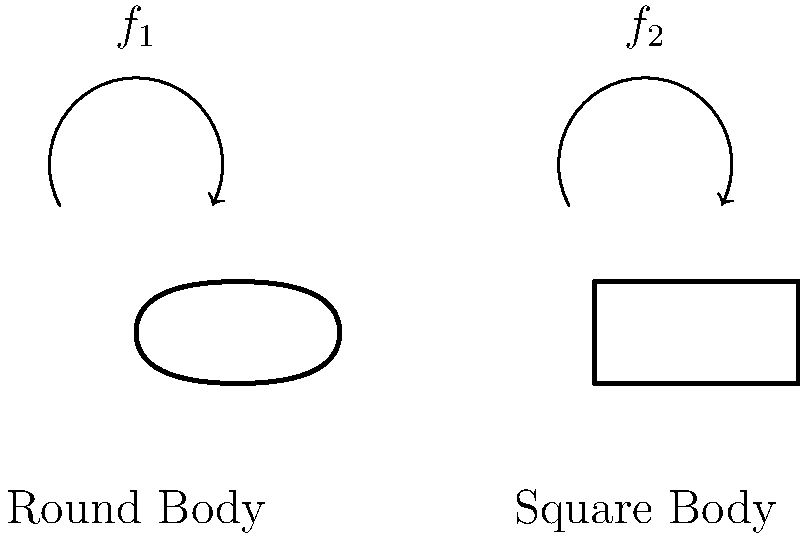As a seasoned musician, you've likely experimented with various guitar shapes. How does the body shape of an acoustic guitar affect its resonant frequency, and which shape typically produces a lower resonant frequency: a round body or a square body? To understand how guitar body shape affects resonant frequency, let's consider the following steps:

1. Resonant frequency is determined by the volume and stiffness of the guitar body.

2. The formula for resonant frequency is:
   $$f = \frac{1}{2\pi}\sqrt{\frac{k}{m}}$$
   where $f$ is frequency, $k$ is stiffness, and $m$ is mass.

3. Round bodies:
   - Have smoother curves, resulting in less stiffness.
   - Distribute vibrations more evenly.
   - Generally have a larger volume.

4. Square bodies:
   - Have sharper corners, increasing stiffness.
   - Concentrate vibrations at corners.
   - Often have a smaller volume.

5. Comparing the two:
   - Round bodies have lower $k$ and higher $m$.
   - Square bodies have higher $k$ and lower $m$.

6. Applying the resonant frequency formula:
   - Lower $k$ and higher $m$ result in a lower frequency.
   - Higher $k$ and lower $m$ result in a higher frequency.

Therefore, round-bodied guitars typically have a lower resonant frequency compared to square-bodied guitars.
Answer: Round body; lower resonant frequency 